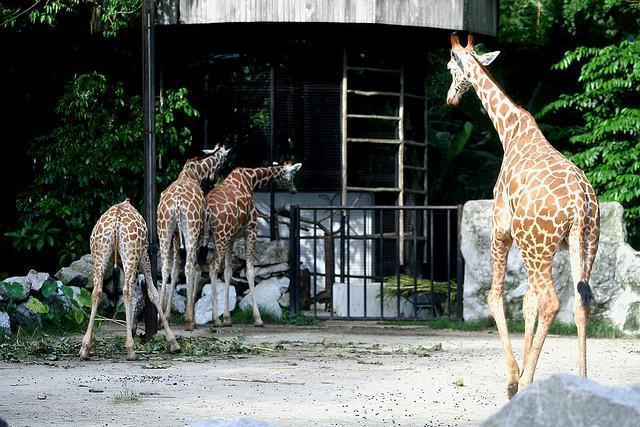How many giraffes are there?
Give a very brief answer. 4. 